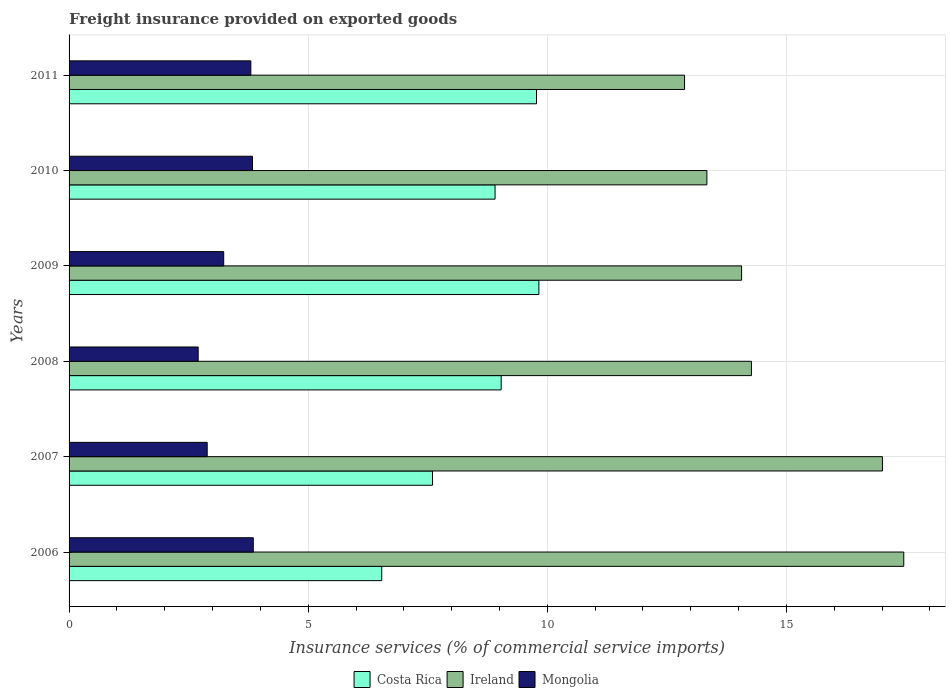How many different coloured bars are there?
Your response must be concise. 3. How many groups of bars are there?
Give a very brief answer. 6. Are the number of bars per tick equal to the number of legend labels?
Your answer should be very brief. Yes. How many bars are there on the 6th tick from the top?
Ensure brevity in your answer.  3. What is the label of the 6th group of bars from the top?
Your answer should be compact. 2006. In how many cases, is the number of bars for a given year not equal to the number of legend labels?
Provide a short and direct response. 0. What is the freight insurance provided on exported goods in Ireland in 2008?
Offer a very short reply. 14.27. Across all years, what is the maximum freight insurance provided on exported goods in Costa Rica?
Ensure brevity in your answer.  9.82. Across all years, what is the minimum freight insurance provided on exported goods in Costa Rica?
Give a very brief answer. 6.54. In which year was the freight insurance provided on exported goods in Costa Rica maximum?
Offer a terse response. 2009. What is the total freight insurance provided on exported goods in Ireland in the graph?
Ensure brevity in your answer.  89. What is the difference between the freight insurance provided on exported goods in Mongolia in 2008 and that in 2010?
Keep it short and to the point. -1.14. What is the difference between the freight insurance provided on exported goods in Costa Rica in 2009 and the freight insurance provided on exported goods in Ireland in 2008?
Offer a terse response. -4.44. What is the average freight insurance provided on exported goods in Costa Rica per year?
Ensure brevity in your answer.  8.61. In the year 2006, what is the difference between the freight insurance provided on exported goods in Costa Rica and freight insurance provided on exported goods in Ireland?
Offer a terse response. -10.92. What is the ratio of the freight insurance provided on exported goods in Costa Rica in 2006 to that in 2008?
Your response must be concise. 0.72. Is the difference between the freight insurance provided on exported goods in Costa Rica in 2008 and 2010 greater than the difference between the freight insurance provided on exported goods in Ireland in 2008 and 2010?
Offer a terse response. No. What is the difference between the highest and the second highest freight insurance provided on exported goods in Mongolia?
Provide a short and direct response. 0.02. What is the difference between the highest and the lowest freight insurance provided on exported goods in Costa Rica?
Ensure brevity in your answer.  3.29. Is the sum of the freight insurance provided on exported goods in Ireland in 2006 and 2010 greater than the maximum freight insurance provided on exported goods in Costa Rica across all years?
Give a very brief answer. Yes. Is it the case that in every year, the sum of the freight insurance provided on exported goods in Costa Rica and freight insurance provided on exported goods in Mongolia is greater than the freight insurance provided on exported goods in Ireland?
Offer a terse response. No. How many bars are there?
Your response must be concise. 18. How many years are there in the graph?
Make the answer very short. 6. Does the graph contain any zero values?
Offer a very short reply. No. How many legend labels are there?
Keep it short and to the point. 3. What is the title of the graph?
Your answer should be very brief. Freight insurance provided on exported goods. Does "France" appear as one of the legend labels in the graph?
Your answer should be very brief. No. What is the label or title of the X-axis?
Provide a short and direct response. Insurance services (% of commercial service imports). What is the label or title of the Y-axis?
Offer a very short reply. Years. What is the Insurance services (% of commercial service imports) of Costa Rica in 2006?
Ensure brevity in your answer.  6.54. What is the Insurance services (% of commercial service imports) of Ireland in 2006?
Keep it short and to the point. 17.45. What is the Insurance services (% of commercial service imports) in Mongolia in 2006?
Ensure brevity in your answer.  3.85. What is the Insurance services (% of commercial service imports) of Costa Rica in 2007?
Your response must be concise. 7.6. What is the Insurance services (% of commercial service imports) in Ireland in 2007?
Ensure brevity in your answer.  17.01. What is the Insurance services (% of commercial service imports) of Mongolia in 2007?
Ensure brevity in your answer.  2.89. What is the Insurance services (% of commercial service imports) in Costa Rica in 2008?
Provide a succinct answer. 9.04. What is the Insurance services (% of commercial service imports) in Ireland in 2008?
Offer a very short reply. 14.27. What is the Insurance services (% of commercial service imports) of Mongolia in 2008?
Make the answer very short. 2.7. What is the Insurance services (% of commercial service imports) in Costa Rica in 2009?
Give a very brief answer. 9.82. What is the Insurance services (% of commercial service imports) of Ireland in 2009?
Your response must be concise. 14.06. What is the Insurance services (% of commercial service imports) of Mongolia in 2009?
Offer a very short reply. 3.23. What is the Insurance services (% of commercial service imports) in Costa Rica in 2010?
Offer a very short reply. 8.91. What is the Insurance services (% of commercial service imports) of Ireland in 2010?
Your answer should be very brief. 13.34. What is the Insurance services (% of commercial service imports) of Mongolia in 2010?
Offer a very short reply. 3.83. What is the Insurance services (% of commercial service imports) in Costa Rica in 2011?
Your response must be concise. 9.77. What is the Insurance services (% of commercial service imports) in Ireland in 2011?
Give a very brief answer. 12.87. What is the Insurance services (% of commercial service imports) of Mongolia in 2011?
Keep it short and to the point. 3.8. Across all years, what is the maximum Insurance services (% of commercial service imports) of Costa Rica?
Give a very brief answer. 9.82. Across all years, what is the maximum Insurance services (% of commercial service imports) of Ireland?
Offer a terse response. 17.45. Across all years, what is the maximum Insurance services (% of commercial service imports) of Mongolia?
Ensure brevity in your answer.  3.85. Across all years, what is the minimum Insurance services (% of commercial service imports) in Costa Rica?
Keep it short and to the point. 6.54. Across all years, what is the minimum Insurance services (% of commercial service imports) of Ireland?
Provide a short and direct response. 12.87. Across all years, what is the minimum Insurance services (% of commercial service imports) of Mongolia?
Offer a terse response. 2.7. What is the total Insurance services (% of commercial service imports) of Costa Rica in the graph?
Your answer should be very brief. 51.68. What is the total Insurance services (% of commercial service imports) of Ireland in the graph?
Offer a terse response. 89. What is the total Insurance services (% of commercial service imports) of Mongolia in the graph?
Keep it short and to the point. 20.31. What is the difference between the Insurance services (% of commercial service imports) of Costa Rica in 2006 and that in 2007?
Your answer should be very brief. -1.06. What is the difference between the Insurance services (% of commercial service imports) of Ireland in 2006 and that in 2007?
Provide a short and direct response. 0.45. What is the difference between the Insurance services (% of commercial service imports) of Mongolia in 2006 and that in 2007?
Offer a very short reply. 0.96. What is the difference between the Insurance services (% of commercial service imports) of Costa Rica in 2006 and that in 2008?
Make the answer very short. -2.5. What is the difference between the Insurance services (% of commercial service imports) of Ireland in 2006 and that in 2008?
Make the answer very short. 3.19. What is the difference between the Insurance services (% of commercial service imports) of Mongolia in 2006 and that in 2008?
Provide a succinct answer. 1.15. What is the difference between the Insurance services (% of commercial service imports) in Costa Rica in 2006 and that in 2009?
Keep it short and to the point. -3.29. What is the difference between the Insurance services (% of commercial service imports) in Ireland in 2006 and that in 2009?
Provide a short and direct response. 3.39. What is the difference between the Insurance services (% of commercial service imports) in Mongolia in 2006 and that in 2009?
Keep it short and to the point. 0.62. What is the difference between the Insurance services (% of commercial service imports) of Costa Rica in 2006 and that in 2010?
Your response must be concise. -2.37. What is the difference between the Insurance services (% of commercial service imports) of Ireland in 2006 and that in 2010?
Ensure brevity in your answer.  4.12. What is the difference between the Insurance services (% of commercial service imports) in Mongolia in 2006 and that in 2010?
Provide a succinct answer. 0.02. What is the difference between the Insurance services (% of commercial service imports) in Costa Rica in 2006 and that in 2011?
Your answer should be very brief. -3.24. What is the difference between the Insurance services (% of commercial service imports) of Ireland in 2006 and that in 2011?
Your response must be concise. 4.58. What is the difference between the Insurance services (% of commercial service imports) in Mongolia in 2006 and that in 2011?
Provide a succinct answer. 0.05. What is the difference between the Insurance services (% of commercial service imports) in Costa Rica in 2007 and that in 2008?
Provide a succinct answer. -1.44. What is the difference between the Insurance services (% of commercial service imports) in Ireland in 2007 and that in 2008?
Your response must be concise. 2.74. What is the difference between the Insurance services (% of commercial service imports) of Mongolia in 2007 and that in 2008?
Offer a terse response. 0.19. What is the difference between the Insurance services (% of commercial service imports) of Costa Rica in 2007 and that in 2009?
Your answer should be very brief. -2.22. What is the difference between the Insurance services (% of commercial service imports) in Ireland in 2007 and that in 2009?
Offer a very short reply. 2.94. What is the difference between the Insurance services (% of commercial service imports) in Mongolia in 2007 and that in 2009?
Ensure brevity in your answer.  -0.35. What is the difference between the Insurance services (% of commercial service imports) of Costa Rica in 2007 and that in 2010?
Your answer should be very brief. -1.31. What is the difference between the Insurance services (% of commercial service imports) in Ireland in 2007 and that in 2010?
Give a very brief answer. 3.67. What is the difference between the Insurance services (% of commercial service imports) of Mongolia in 2007 and that in 2010?
Ensure brevity in your answer.  -0.95. What is the difference between the Insurance services (% of commercial service imports) of Costa Rica in 2007 and that in 2011?
Your answer should be compact. -2.17. What is the difference between the Insurance services (% of commercial service imports) in Ireland in 2007 and that in 2011?
Make the answer very short. 4.14. What is the difference between the Insurance services (% of commercial service imports) of Mongolia in 2007 and that in 2011?
Your response must be concise. -0.91. What is the difference between the Insurance services (% of commercial service imports) in Costa Rica in 2008 and that in 2009?
Your response must be concise. -0.79. What is the difference between the Insurance services (% of commercial service imports) of Ireland in 2008 and that in 2009?
Give a very brief answer. 0.21. What is the difference between the Insurance services (% of commercial service imports) in Mongolia in 2008 and that in 2009?
Keep it short and to the point. -0.53. What is the difference between the Insurance services (% of commercial service imports) in Costa Rica in 2008 and that in 2010?
Your answer should be compact. 0.13. What is the difference between the Insurance services (% of commercial service imports) in Ireland in 2008 and that in 2010?
Your response must be concise. 0.93. What is the difference between the Insurance services (% of commercial service imports) in Mongolia in 2008 and that in 2010?
Give a very brief answer. -1.14. What is the difference between the Insurance services (% of commercial service imports) of Costa Rica in 2008 and that in 2011?
Your answer should be compact. -0.74. What is the difference between the Insurance services (% of commercial service imports) in Ireland in 2008 and that in 2011?
Keep it short and to the point. 1.4. What is the difference between the Insurance services (% of commercial service imports) in Mongolia in 2008 and that in 2011?
Provide a short and direct response. -1.1. What is the difference between the Insurance services (% of commercial service imports) in Costa Rica in 2009 and that in 2010?
Offer a terse response. 0.92. What is the difference between the Insurance services (% of commercial service imports) in Ireland in 2009 and that in 2010?
Keep it short and to the point. 0.73. What is the difference between the Insurance services (% of commercial service imports) of Mongolia in 2009 and that in 2010?
Your response must be concise. -0.6. What is the difference between the Insurance services (% of commercial service imports) in Costa Rica in 2009 and that in 2011?
Keep it short and to the point. 0.05. What is the difference between the Insurance services (% of commercial service imports) of Ireland in 2009 and that in 2011?
Keep it short and to the point. 1.19. What is the difference between the Insurance services (% of commercial service imports) of Mongolia in 2009 and that in 2011?
Ensure brevity in your answer.  -0.57. What is the difference between the Insurance services (% of commercial service imports) of Costa Rica in 2010 and that in 2011?
Offer a very short reply. -0.87. What is the difference between the Insurance services (% of commercial service imports) of Ireland in 2010 and that in 2011?
Make the answer very short. 0.47. What is the difference between the Insurance services (% of commercial service imports) of Mongolia in 2010 and that in 2011?
Ensure brevity in your answer.  0.03. What is the difference between the Insurance services (% of commercial service imports) of Costa Rica in 2006 and the Insurance services (% of commercial service imports) of Ireland in 2007?
Your answer should be compact. -10.47. What is the difference between the Insurance services (% of commercial service imports) in Costa Rica in 2006 and the Insurance services (% of commercial service imports) in Mongolia in 2007?
Provide a succinct answer. 3.65. What is the difference between the Insurance services (% of commercial service imports) in Ireland in 2006 and the Insurance services (% of commercial service imports) in Mongolia in 2007?
Keep it short and to the point. 14.57. What is the difference between the Insurance services (% of commercial service imports) of Costa Rica in 2006 and the Insurance services (% of commercial service imports) of Ireland in 2008?
Make the answer very short. -7.73. What is the difference between the Insurance services (% of commercial service imports) of Costa Rica in 2006 and the Insurance services (% of commercial service imports) of Mongolia in 2008?
Keep it short and to the point. 3.84. What is the difference between the Insurance services (% of commercial service imports) in Ireland in 2006 and the Insurance services (% of commercial service imports) in Mongolia in 2008?
Your response must be concise. 14.75. What is the difference between the Insurance services (% of commercial service imports) of Costa Rica in 2006 and the Insurance services (% of commercial service imports) of Ireland in 2009?
Your answer should be compact. -7.53. What is the difference between the Insurance services (% of commercial service imports) in Costa Rica in 2006 and the Insurance services (% of commercial service imports) in Mongolia in 2009?
Offer a very short reply. 3.3. What is the difference between the Insurance services (% of commercial service imports) of Ireland in 2006 and the Insurance services (% of commercial service imports) of Mongolia in 2009?
Make the answer very short. 14.22. What is the difference between the Insurance services (% of commercial service imports) of Costa Rica in 2006 and the Insurance services (% of commercial service imports) of Ireland in 2010?
Your answer should be compact. -6.8. What is the difference between the Insurance services (% of commercial service imports) in Costa Rica in 2006 and the Insurance services (% of commercial service imports) in Mongolia in 2010?
Provide a succinct answer. 2.7. What is the difference between the Insurance services (% of commercial service imports) of Ireland in 2006 and the Insurance services (% of commercial service imports) of Mongolia in 2010?
Your answer should be compact. 13.62. What is the difference between the Insurance services (% of commercial service imports) in Costa Rica in 2006 and the Insurance services (% of commercial service imports) in Ireland in 2011?
Your answer should be very brief. -6.33. What is the difference between the Insurance services (% of commercial service imports) in Costa Rica in 2006 and the Insurance services (% of commercial service imports) in Mongolia in 2011?
Give a very brief answer. 2.74. What is the difference between the Insurance services (% of commercial service imports) of Ireland in 2006 and the Insurance services (% of commercial service imports) of Mongolia in 2011?
Keep it short and to the point. 13.65. What is the difference between the Insurance services (% of commercial service imports) in Costa Rica in 2007 and the Insurance services (% of commercial service imports) in Ireland in 2008?
Ensure brevity in your answer.  -6.67. What is the difference between the Insurance services (% of commercial service imports) of Costa Rica in 2007 and the Insurance services (% of commercial service imports) of Mongolia in 2008?
Give a very brief answer. 4.9. What is the difference between the Insurance services (% of commercial service imports) of Ireland in 2007 and the Insurance services (% of commercial service imports) of Mongolia in 2008?
Offer a terse response. 14.31. What is the difference between the Insurance services (% of commercial service imports) of Costa Rica in 2007 and the Insurance services (% of commercial service imports) of Ireland in 2009?
Ensure brevity in your answer.  -6.46. What is the difference between the Insurance services (% of commercial service imports) of Costa Rica in 2007 and the Insurance services (% of commercial service imports) of Mongolia in 2009?
Offer a very short reply. 4.37. What is the difference between the Insurance services (% of commercial service imports) of Ireland in 2007 and the Insurance services (% of commercial service imports) of Mongolia in 2009?
Keep it short and to the point. 13.77. What is the difference between the Insurance services (% of commercial service imports) in Costa Rica in 2007 and the Insurance services (% of commercial service imports) in Ireland in 2010?
Offer a terse response. -5.74. What is the difference between the Insurance services (% of commercial service imports) of Costa Rica in 2007 and the Insurance services (% of commercial service imports) of Mongolia in 2010?
Give a very brief answer. 3.77. What is the difference between the Insurance services (% of commercial service imports) in Ireland in 2007 and the Insurance services (% of commercial service imports) in Mongolia in 2010?
Your answer should be very brief. 13.17. What is the difference between the Insurance services (% of commercial service imports) in Costa Rica in 2007 and the Insurance services (% of commercial service imports) in Ireland in 2011?
Provide a short and direct response. -5.27. What is the difference between the Insurance services (% of commercial service imports) of Costa Rica in 2007 and the Insurance services (% of commercial service imports) of Mongolia in 2011?
Offer a terse response. 3.8. What is the difference between the Insurance services (% of commercial service imports) of Ireland in 2007 and the Insurance services (% of commercial service imports) of Mongolia in 2011?
Make the answer very short. 13.21. What is the difference between the Insurance services (% of commercial service imports) of Costa Rica in 2008 and the Insurance services (% of commercial service imports) of Ireland in 2009?
Your response must be concise. -5.03. What is the difference between the Insurance services (% of commercial service imports) of Costa Rica in 2008 and the Insurance services (% of commercial service imports) of Mongolia in 2009?
Keep it short and to the point. 5.8. What is the difference between the Insurance services (% of commercial service imports) in Ireland in 2008 and the Insurance services (% of commercial service imports) in Mongolia in 2009?
Provide a short and direct response. 11.04. What is the difference between the Insurance services (% of commercial service imports) in Costa Rica in 2008 and the Insurance services (% of commercial service imports) in Ireland in 2010?
Your response must be concise. -4.3. What is the difference between the Insurance services (% of commercial service imports) in Costa Rica in 2008 and the Insurance services (% of commercial service imports) in Mongolia in 2010?
Make the answer very short. 5.2. What is the difference between the Insurance services (% of commercial service imports) in Ireland in 2008 and the Insurance services (% of commercial service imports) in Mongolia in 2010?
Offer a terse response. 10.43. What is the difference between the Insurance services (% of commercial service imports) in Costa Rica in 2008 and the Insurance services (% of commercial service imports) in Ireland in 2011?
Provide a succinct answer. -3.83. What is the difference between the Insurance services (% of commercial service imports) of Costa Rica in 2008 and the Insurance services (% of commercial service imports) of Mongolia in 2011?
Provide a short and direct response. 5.24. What is the difference between the Insurance services (% of commercial service imports) in Ireland in 2008 and the Insurance services (% of commercial service imports) in Mongolia in 2011?
Your response must be concise. 10.47. What is the difference between the Insurance services (% of commercial service imports) in Costa Rica in 2009 and the Insurance services (% of commercial service imports) in Ireland in 2010?
Keep it short and to the point. -3.51. What is the difference between the Insurance services (% of commercial service imports) of Costa Rica in 2009 and the Insurance services (% of commercial service imports) of Mongolia in 2010?
Your answer should be compact. 5.99. What is the difference between the Insurance services (% of commercial service imports) of Ireland in 2009 and the Insurance services (% of commercial service imports) of Mongolia in 2010?
Offer a terse response. 10.23. What is the difference between the Insurance services (% of commercial service imports) of Costa Rica in 2009 and the Insurance services (% of commercial service imports) of Ireland in 2011?
Your answer should be compact. -3.05. What is the difference between the Insurance services (% of commercial service imports) in Costa Rica in 2009 and the Insurance services (% of commercial service imports) in Mongolia in 2011?
Ensure brevity in your answer.  6.02. What is the difference between the Insurance services (% of commercial service imports) of Ireland in 2009 and the Insurance services (% of commercial service imports) of Mongolia in 2011?
Provide a succinct answer. 10.26. What is the difference between the Insurance services (% of commercial service imports) of Costa Rica in 2010 and the Insurance services (% of commercial service imports) of Ireland in 2011?
Keep it short and to the point. -3.96. What is the difference between the Insurance services (% of commercial service imports) of Costa Rica in 2010 and the Insurance services (% of commercial service imports) of Mongolia in 2011?
Make the answer very short. 5.11. What is the difference between the Insurance services (% of commercial service imports) in Ireland in 2010 and the Insurance services (% of commercial service imports) in Mongolia in 2011?
Offer a very short reply. 9.54. What is the average Insurance services (% of commercial service imports) in Costa Rica per year?
Offer a very short reply. 8.61. What is the average Insurance services (% of commercial service imports) in Ireland per year?
Provide a succinct answer. 14.83. What is the average Insurance services (% of commercial service imports) in Mongolia per year?
Offer a terse response. 3.38. In the year 2006, what is the difference between the Insurance services (% of commercial service imports) of Costa Rica and Insurance services (% of commercial service imports) of Ireland?
Offer a very short reply. -10.92. In the year 2006, what is the difference between the Insurance services (% of commercial service imports) of Costa Rica and Insurance services (% of commercial service imports) of Mongolia?
Offer a terse response. 2.69. In the year 2006, what is the difference between the Insurance services (% of commercial service imports) in Ireland and Insurance services (% of commercial service imports) in Mongolia?
Offer a very short reply. 13.6. In the year 2007, what is the difference between the Insurance services (% of commercial service imports) in Costa Rica and Insurance services (% of commercial service imports) in Ireland?
Your answer should be very brief. -9.41. In the year 2007, what is the difference between the Insurance services (% of commercial service imports) in Costa Rica and Insurance services (% of commercial service imports) in Mongolia?
Keep it short and to the point. 4.71. In the year 2007, what is the difference between the Insurance services (% of commercial service imports) of Ireland and Insurance services (% of commercial service imports) of Mongolia?
Provide a short and direct response. 14.12. In the year 2008, what is the difference between the Insurance services (% of commercial service imports) in Costa Rica and Insurance services (% of commercial service imports) in Ireland?
Ensure brevity in your answer.  -5.23. In the year 2008, what is the difference between the Insurance services (% of commercial service imports) of Costa Rica and Insurance services (% of commercial service imports) of Mongolia?
Make the answer very short. 6.34. In the year 2008, what is the difference between the Insurance services (% of commercial service imports) of Ireland and Insurance services (% of commercial service imports) of Mongolia?
Ensure brevity in your answer.  11.57. In the year 2009, what is the difference between the Insurance services (% of commercial service imports) of Costa Rica and Insurance services (% of commercial service imports) of Ireland?
Provide a short and direct response. -4.24. In the year 2009, what is the difference between the Insurance services (% of commercial service imports) in Costa Rica and Insurance services (% of commercial service imports) in Mongolia?
Offer a terse response. 6.59. In the year 2009, what is the difference between the Insurance services (% of commercial service imports) in Ireland and Insurance services (% of commercial service imports) in Mongolia?
Give a very brief answer. 10.83. In the year 2010, what is the difference between the Insurance services (% of commercial service imports) in Costa Rica and Insurance services (% of commercial service imports) in Ireland?
Offer a very short reply. -4.43. In the year 2010, what is the difference between the Insurance services (% of commercial service imports) of Costa Rica and Insurance services (% of commercial service imports) of Mongolia?
Your answer should be compact. 5.07. In the year 2010, what is the difference between the Insurance services (% of commercial service imports) in Ireland and Insurance services (% of commercial service imports) in Mongolia?
Offer a terse response. 9.5. In the year 2011, what is the difference between the Insurance services (% of commercial service imports) of Costa Rica and Insurance services (% of commercial service imports) of Ireland?
Give a very brief answer. -3.1. In the year 2011, what is the difference between the Insurance services (% of commercial service imports) in Costa Rica and Insurance services (% of commercial service imports) in Mongolia?
Give a very brief answer. 5.97. In the year 2011, what is the difference between the Insurance services (% of commercial service imports) in Ireland and Insurance services (% of commercial service imports) in Mongolia?
Your response must be concise. 9.07. What is the ratio of the Insurance services (% of commercial service imports) in Costa Rica in 2006 to that in 2007?
Ensure brevity in your answer.  0.86. What is the ratio of the Insurance services (% of commercial service imports) in Ireland in 2006 to that in 2007?
Offer a terse response. 1.03. What is the ratio of the Insurance services (% of commercial service imports) in Mongolia in 2006 to that in 2007?
Give a very brief answer. 1.33. What is the ratio of the Insurance services (% of commercial service imports) of Costa Rica in 2006 to that in 2008?
Keep it short and to the point. 0.72. What is the ratio of the Insurance services (% of commercial service imports) in Ireland in 2006 to that in 2008?
Make the answer very short. 1.22. What is the ratio of the Insurance services (% of commercial service imports) in Mongolia in 2006 to that in 2008?
Offer a terse response. 1.43. What is the ratio of the Insurance services (% of commercial service imports) of Costa Rica in 2006 to that in 2009?
Offer a terse response. 0.67. What is the ratio of the Insurance services (% of commercial service imports) in Ireland in 2006 to that in 2009?
Make the answer very short. 1.24. What is the ratio of the Insurance services (% of commercial service imports) of Mongolia in 2006 to that in 2009?
Provide a short and direct response. 1.19. What is the ratio of the Insurance services (% of commercial service imports) in Costa Rica in 2006 to that in 2010?
Provide a short and direct response. 0.73. What is the ratio of the Insurance services (% of commercial service imports) of Ireland in 2006 to that in 2010?
Provide a succinct answer. 1.31. What is the ratio of the Insurance services (% of commercial service imports) in Costa Rica in 2006 to that in 2011?
Your answer should be compact. 0.67. What is the ratio of the Insurance services (% of commercial service imports) of Ireland in 2006 to that in 2011?
Offer a very short reply. 1.36. What is the ratio of the Insurance services (% of commercial service imports) in Mongolia in 2006 to that in 2011?
Offer a very short reply. 1.01. What is the ratio of the Insurance services (% of commercial service imports) in Costa Rica in 2007 to that in 2008?
Make the answer very short. 0.84. What is the ratio of the Insurance services (% of commercial service imports) in Ireland in 2007 to that in 2008?
Your response must be concise. 1.19. What is the ratio of the Insurance services (% of commercial service imports) in Mongolia in 2007 to that in 2008?
Offer a very short reply. 1.07. What is the ratio of the Insurance services (% of commercial service imports) of Costa Rica in 2007 to that in 2009?
Ensure brevity in your answer.  0.77. What is the ratio of the Insurance services (% of commercial service imports) in Ireland in 2007 to that in 2009?
Keep it short and to the point. 1.21. What is the ratio of the Insurance services (% of commercial service imports) of Mongolia in 2007 to that in 2009?
Offer a very short reply. 0.89. What is the ratio of the Insurance services (% of commercial service imports) in Costa Rica in 2007 to that in 2010?
Keep it short and to the point. 0.85. What is the ratio of the Insurance services (% of commercial service imports) of Ireland in 2007 to that in 2010?
Keep it short and to the point. 1.28. What is the ratio of the Insurance services (% of commercial service imports) of Mongolia in 2007 to that in 2010?
Provide a succinct answer. 0.75. What is the ratio of the Insurance services (% of commercial service imports) of Costa Rica in 2007 to that in 2011?
Provide a succinct answer. 0.78. What is the ratio of the Insurance services (% of commercial service imports) in Ireland in 2007 to that in 2011?
Your response must be concise. 1.32. What is the ratio of the Insurance services (% of commercial service imports) in Mongolia in 2007 to that in 2011?
Ensure brevity in your answer.  0.76. What is the ratio of the Insurance services (% of commercial service imports) of Costa Rica in 2008 to that in 2009?
Give a very brief answer. 0.92. What is the ratio of the Insurance services (% of commercial service imports) in Ireland in 2008 to that in 2009?
Ensure brevity in your answer.  1.01. What is the ratio of the Insurance services (% of commercial service imports) in Mongolia in 2008 to that in 2009?
Your answer should be very brief. 0.83. What is the ratio of the Insurance services (% of commercial service imports) in Costa Rica in 2008 to that in 2010?
Your answer should be compact. 1.01. What is the ratio of the Insurance services (% of commercial service imports) of Ireland in 2008 to that in 2010?
Offer a very short reply. 1.07. What is the ratio of the Insurance services (% of commercial service imports) of Mongolia in 2008 to that in 2010?
Ensure brevity in your answer.  0.7. What is the ratio of the Insurance services (% of commercial service imports) of Costa Rica in 2008 to that in 2011?
Ensure brevity in your answer.  0.92. What is the ratio of the Insurance services (% of commercial service imports) in Ireland in 2008 to that in 2011?
Make the answer very short. 1.11. What is the ratio of the Insurance services (% of commercial service imports) of Mongolia in 2008 to that in 2011?
Ensure brevity in your answer.  0.71. What is the ratio of the Insurance services (% of commercial service imports) of Costa Rica in 2009 to that in 2010?
Your answer should be very brief. 1.1. What is the ratio of the Insurance services (% of commercial service imports) in Ireland in 2009 to that in 2010?
Provide a succinct answer. 1.05. What is the ratio of the Insurance services (% of commercial service imports) in Mongolia in 2009 to that in 2010?
Your response must be concise. 0.84. What is the ratio of the Insurance services (% of commercial service imports) of Ireland in 2009 to that in 2011?
Give a very brief answer. 1.09. What is the ratio of the Insurance services (% of commercial service imports) of Mongolia in 2009 to that in 2011?
Offer a very short reply. 0.85. What is the ratio of the Insurance services (% of commercial service imports) in Costa Rica in 2010 to that in 2011?
Your response must be concise. 0.91. What is the ratio of the Insurance services (% of commercial service imports) of Ireland in 2010 to that in 2011?
Your response must be concise. 1.04. What is the ratio of the Insurance services (% of commercial service imports) in Mongolia in 2010 to that in 2011?
Provide a succinct answer. 1.01. What is the difference between the highest and the second highest Insurance services (% of commercial service imports) in Costa Rica?
Ensure brevity in your answer.  0.05. What is the difference between the highest and the second highest Insurance services (% of commercial service imports) of Ireland?
Your answer should be compact. 0.45. What is the difference between the highest and the second highest Insurance services (% of commercial service imports) of Mongolia?
Provide a short and direct response. 0.02. What is the difference between the highest and the lowest Insurance services (% of commercial service imports) in Costa Rica?
Your answer should be very brief. 3.29. What is the difference between the highest and the lowest Insurance services (% of commercial service imports) in Ireland?
Your answer should be compact. 4.58. What is the difference between the highest and the lowest Insurance services (% of commercial service imports) of Mongolia?
Provide a short and direct response. 1.15. 